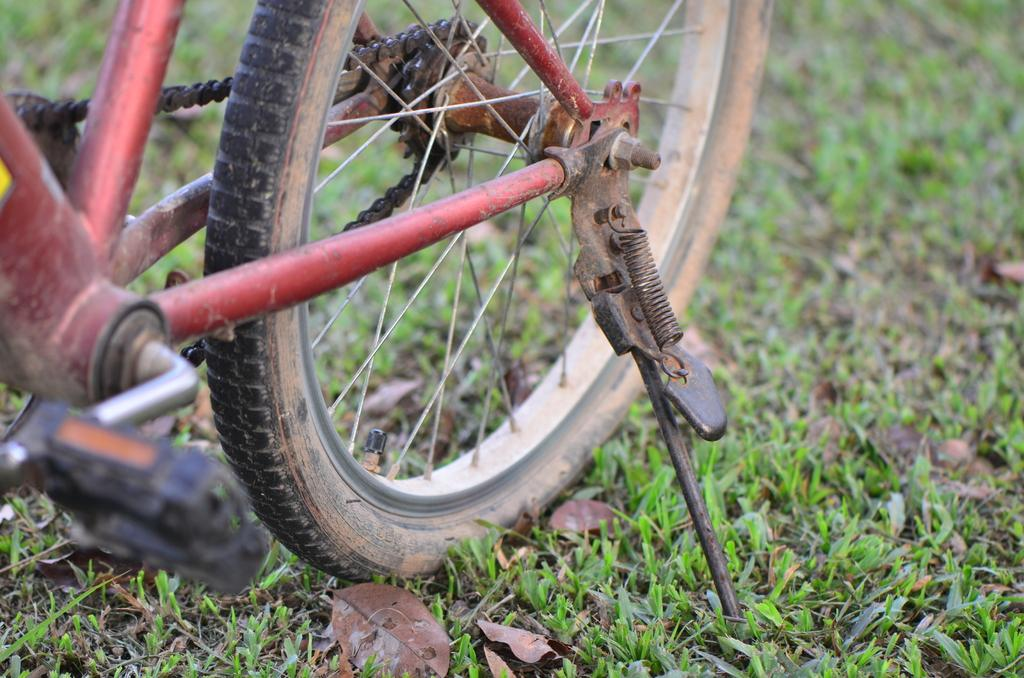What part of a bicycle is shown in the image? The rear wheel of a bicycle is shown in the image. What can be observed about the structure of the wheel? The wheel has spokes. What is the additional feature visible in the image? There is a side stand in the image. What component is used for propulsion in the image? A pedal is visible in the image. What connects the pedal to the wheel in the image? A chain is present in the image. What type of coat is hanging on the rake in the image? There is no coat or rake present in the image; it only features a rear wheel of a bicycle, a side stand, a pedal, and a chain. 